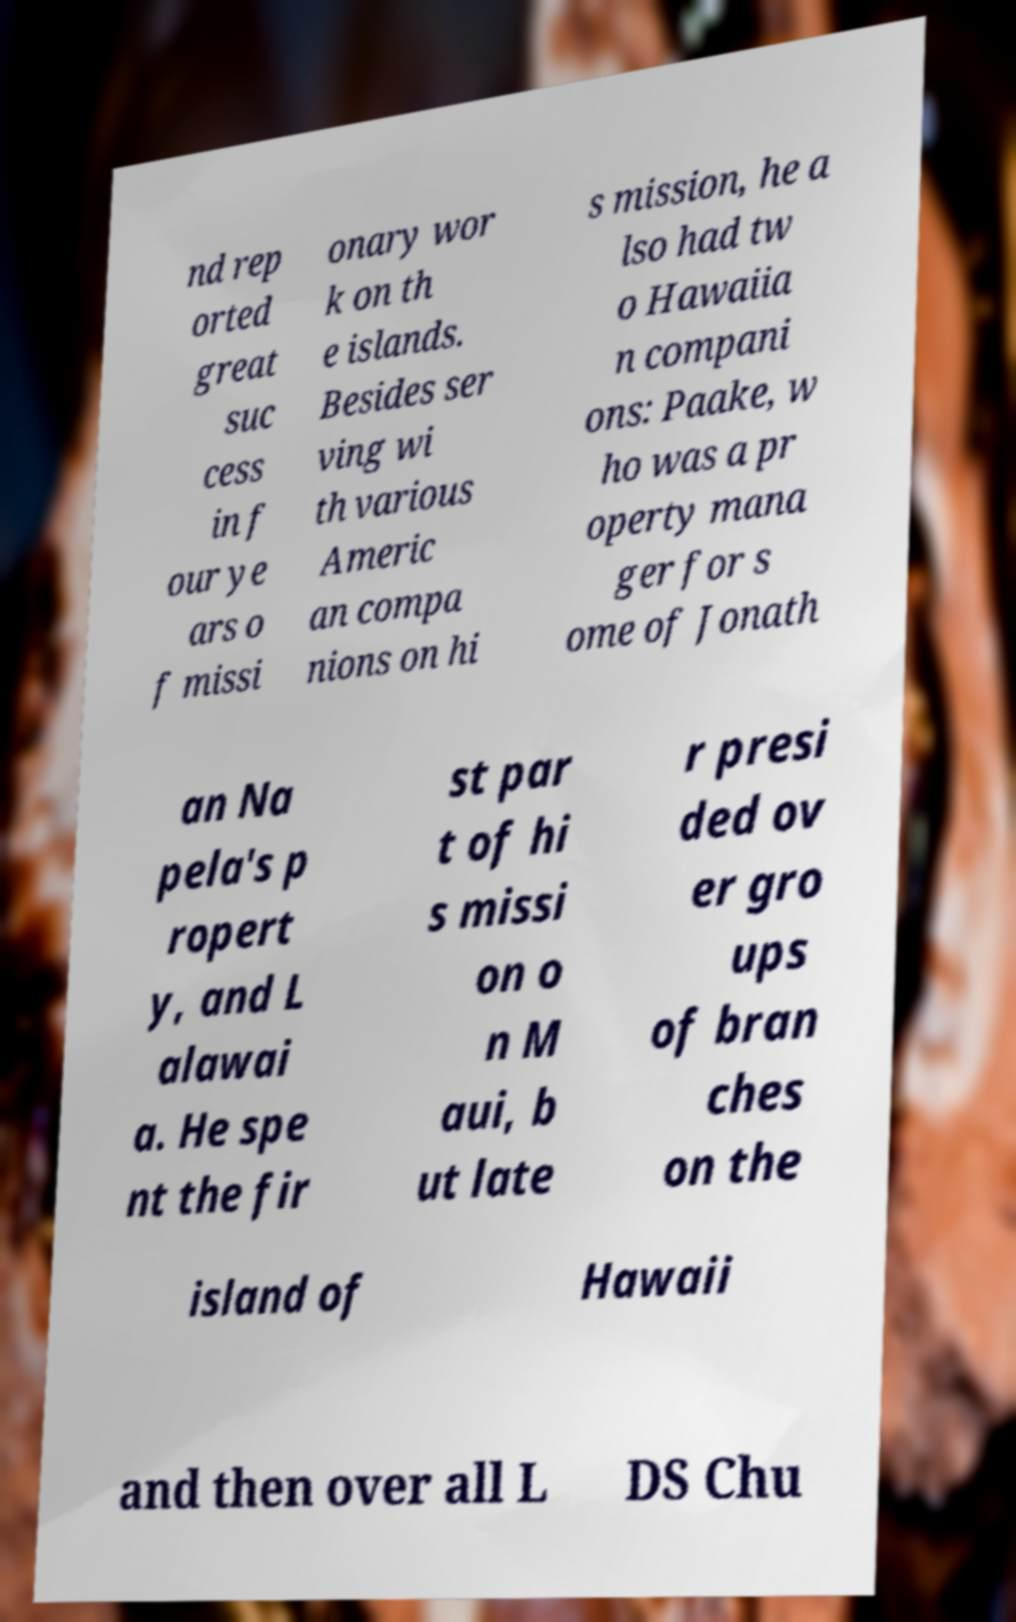There's text embedded in this image that I need extracted. Can you transcribe it verbatim? nd rep orted great suc cess in f our ye ars o f missi onary wor k on th e islands. Besides ser ving wi th various Americ an compa nions on hi s mission, he a lso had tw o Hawaiia n compani ons: Paake, w ho was a pr operty mana ger for s ome of Jonath an Na pela's p ropert y, and L alawai a. He spe nt the fir st par t of hi s missi on o n M aui, b ut late r presi ded ov er gro ups of bran ches on the island of Hawaii and then over all L DS Chu 